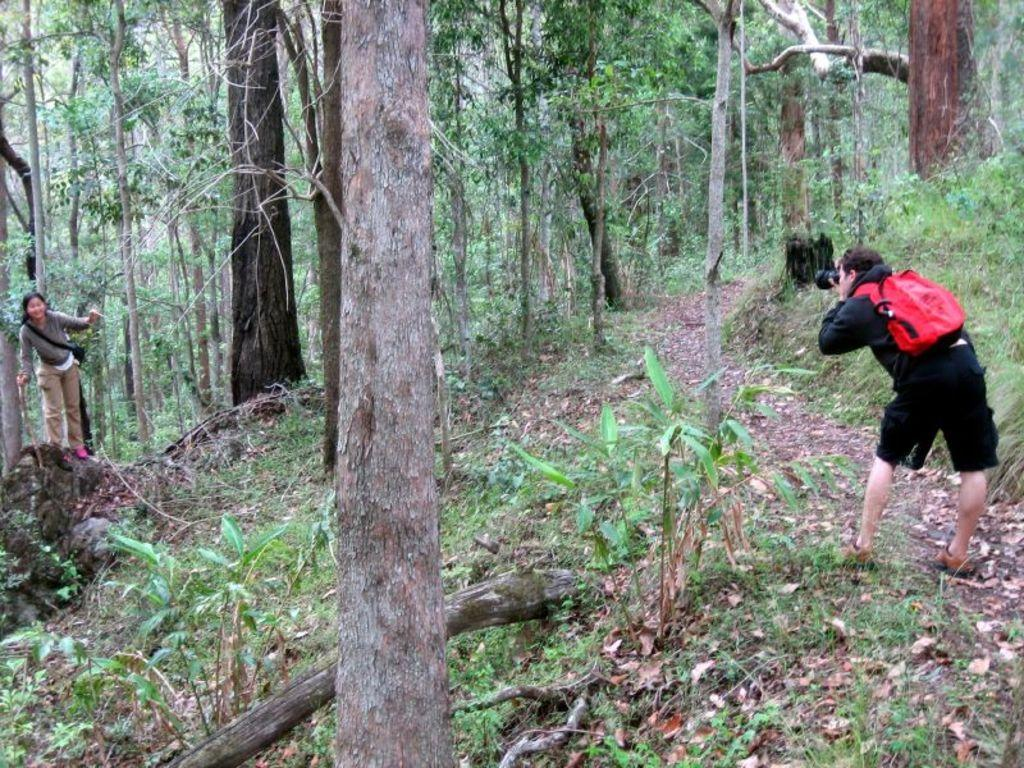How many people are in the image? There are two persons in the image. What are the persons holding in their hands? The persons are holding objects in their hands. What type of natural elements can be seen in the image? There are trees and plants in the image. What type of cream can be seen on the toad in the image? There is no toad or cream present in the image. What tax is being discussed by the persons in the image? There is no discussion of taxes in the image; the persons are holding objects in their hands. 